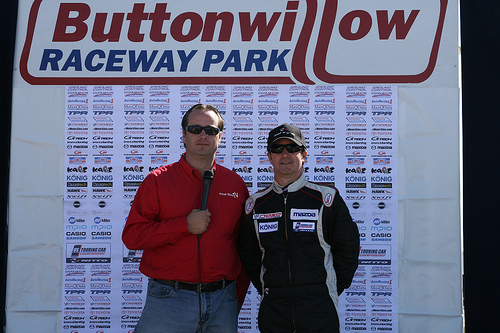<image>
Is there a promotion behind the driver? Yes. From this viewpoint, the promotion is positioned behind the driver, with the driver partially or fully occluding the promotion. 